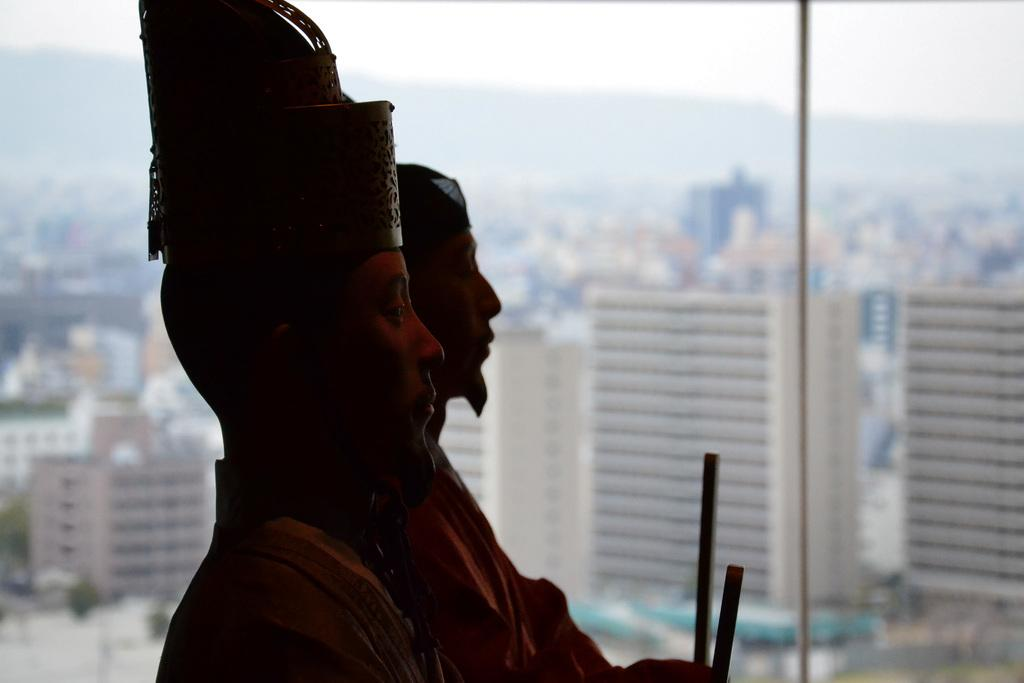What type of objects are depicted as statues in the image? There are statues of persons in the image. What other objects can be seen in the image besides the statues? There are rods and glass visible in the image. What can be seen through the glass in the image? Buildings, mountains, and the sky can be seen through the glass. How many pies are being held by the statues in the image? There are no pies present in the image; the statues are not holding any objects. What type of respect is being shown by the statues in the image? The statues are not capable of showing respect, as they are inanimate objects. 